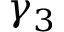<formula> <loc_0><loc_0><loc_500><loc_500>\gamma _ { 3 }</formula> 